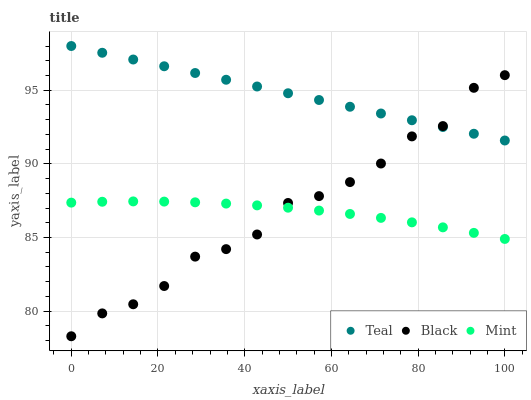Does Mint have the minimum area under the curve?
Answer yes or no. Yes. Does Teal have the maximum area under the curve?
Answer yes or no. Yes. Does Black have the minimum area under the curve?
Answer yes or no. No. Does Black have the maximum area under the curve?
Answer yes or no. No. Is Teal the smoothest?
Answer yes or no. Yes. Is Black the roughest?
Answer yes or no. Yes. Is Black the smoothest?
Answer yes or no. No. Is Teal the roughest?
Answer yes or no. No. Does Black have the lowest value?
Answer yes or no. Yes. Does Teal have the lowest value?
Answer yes or no. No. Does Teal have the highest value?
Answer yes or no. Yes. Does Black have the highest value?
Answer yes or no. No. Is Mint less than Teal?
Answer yes or no. Yes. Is Teal greater than Mint?
Answer yes or no. Yes. Does Black intersect Teal?
Answer yes or no. Yes. Is Black less than Teal?
Answer yes or no. No. Is Black greater than Teal?
Answer yes or no. No. Does Mint intersect Teal?
Answer yes or no. No. 